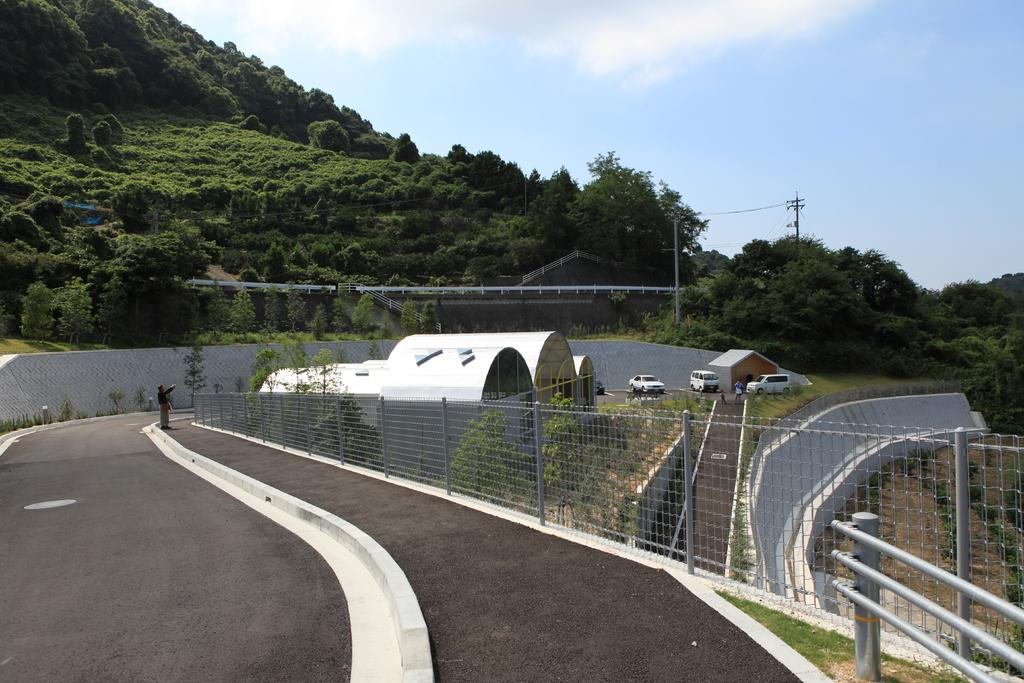What type of vegetation can be seen in the image? There are trees in the image. What can be seen parked in the image? There are cars parked in the image. What type of building is visible in the image? There is a house in the image. What is the condition of the sky in the image? The sky is blue and cloudy in the image. What type of barrier is present in the image? There is a metal fence in the image. Can you describe the person in the image? There is a man standing on the road in the image. What type of marble is being used to play a game in the image? There is no marble or game present in the image. What type of pan is being used to cook in the image? There is no pan or cooking activity present in the image. 